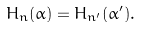Convert formula to latex. <formula><loc_0><loc_0><loc_500><loc_500>H _ { n } ( \alpha ) = H _ { n ^ { \prime } } ( \alpha ^ { \prime } ) .</formula> 